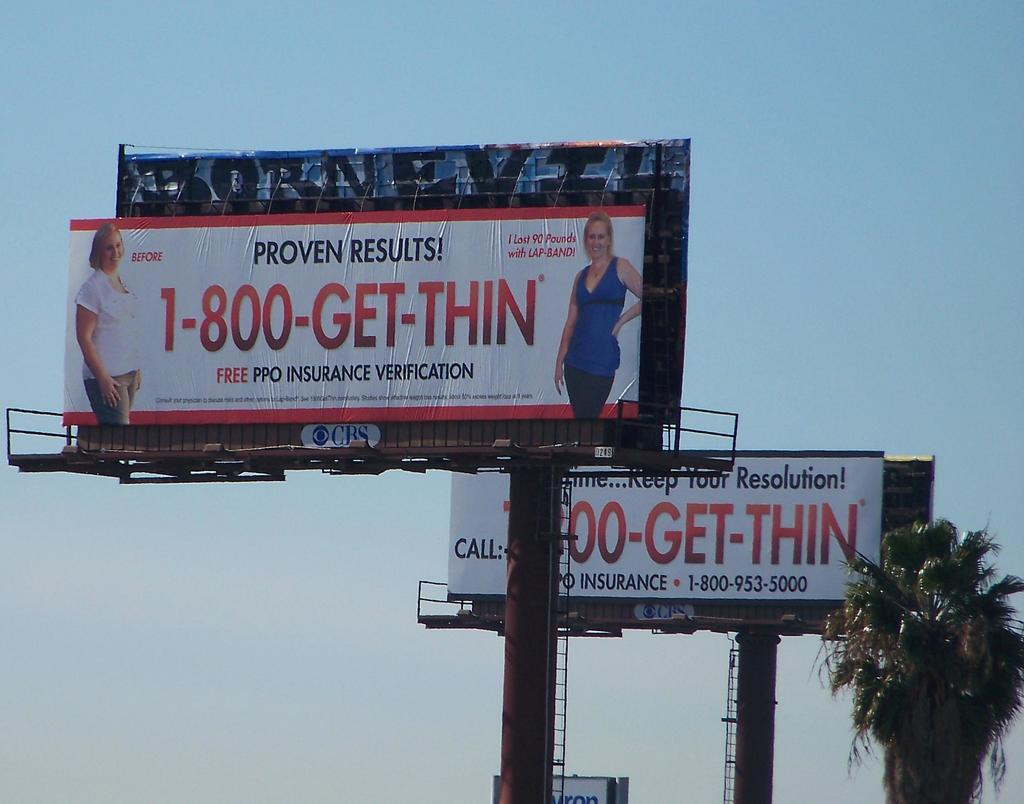<image>
Render a clear and concise summary of the photo. Two billboards advertising a solution to get thin fast stand beside a palm tree. 